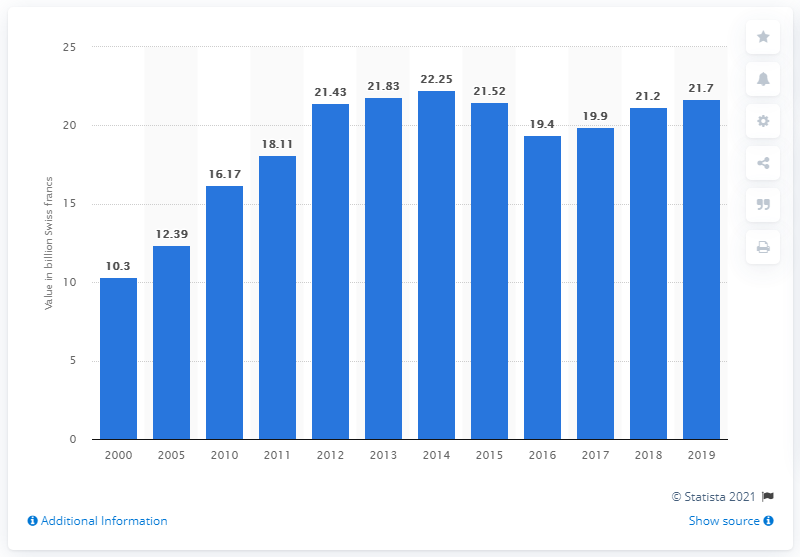Mention a couple of crucial points in this snapshot. In 2019, the value of Swiss watch exports was 21.7 billion Swiss francs. 